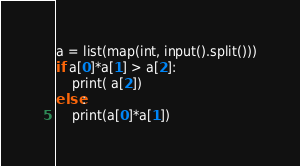Convert code to text. <code><loc_0><loc_0><loc_500><loc_500><_Ruby_>a = list(map(int, input().split()))
if a[0]*a[1] > a[2]:
    print( a[2])
else:
    print(a[0]*a[1])</code> 